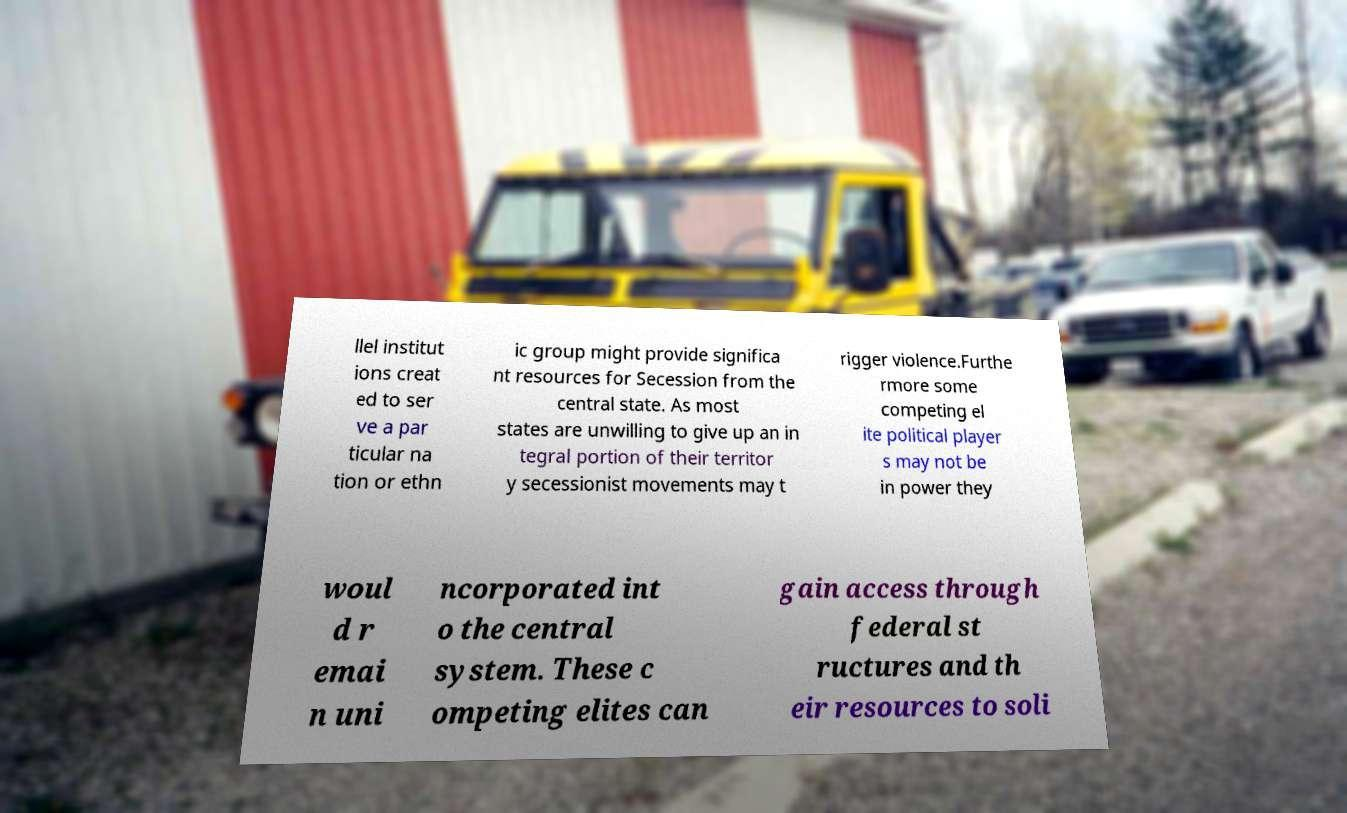Can you read and provide the text displayed in the image?This photo seems to have some interesting text. Can you extract and type it out for me? llel institut ions creat ed to ser ve a par ticular na tion or ethn ic group might provide significa nt resources for Secession from the central state. As most states are unwilling to give up an in tegral portion of their territor y secessionist movements may t rigger violence.Furthe rmore some competing el ite political player s may not be in power they woul d r emai n uni ncorporated int o the central system. These c ompeting elites can gain access through federal st ructures and th eir resources to soli 